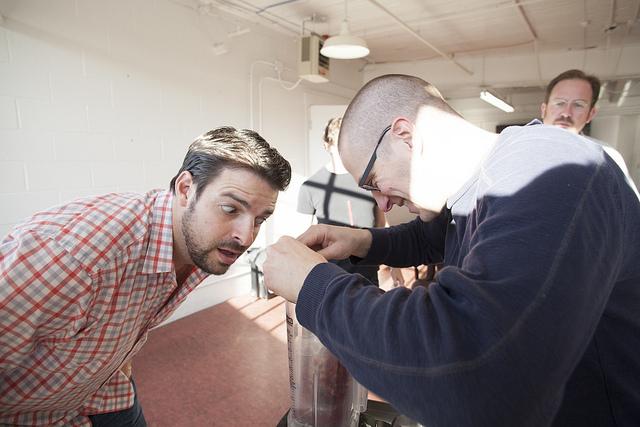What are the people doing here?
Be succinct. Playing game. Is the man wearing glasses?
Write a very short answer. Yes. What color is the photo?
Keep it brief. Multiple. Are these individuals creating an experiment?
Short answer required. Yes. What are the men doing?
Write a very short answer. Staring. Is this a convention?
Short answer required. No. Is this a kitchen?
Be succinct. No. What is the man holding?
Short answer required. Blender. Is this a recent photo?
Be succinct. Yes. Is he wearing a hat?
Be succinct. No. How many people are in the photo?
Be succinct. 3. Are the two people chefs?
Keep it brief. No. What system are they playing this game on?
Keep it brief. None. What is he watching?
Concise answer only. Blender. What are they playing?
Give a very brief answer. Blender. What color is the man's shirt on the right?
Concise answer only. Blue. What color is the pourers shirt?
Short answer required. Blue. How many people in the room?
Answer briefly. 4. Is the man old or young?
Write a very short answer. Young. What is on the man's shoulder?
Quick response, please. Sunlight. Are these people working?
Keep it brief. Yes. How many people are there?
Quick response, please. 3. Who is wearing a white button up shirt?
Write a very short answer. No one. Is anyone looking directly at the camera?
Keep it brief. No. What profession to these people appear to have?
Short answer required. Cook. 